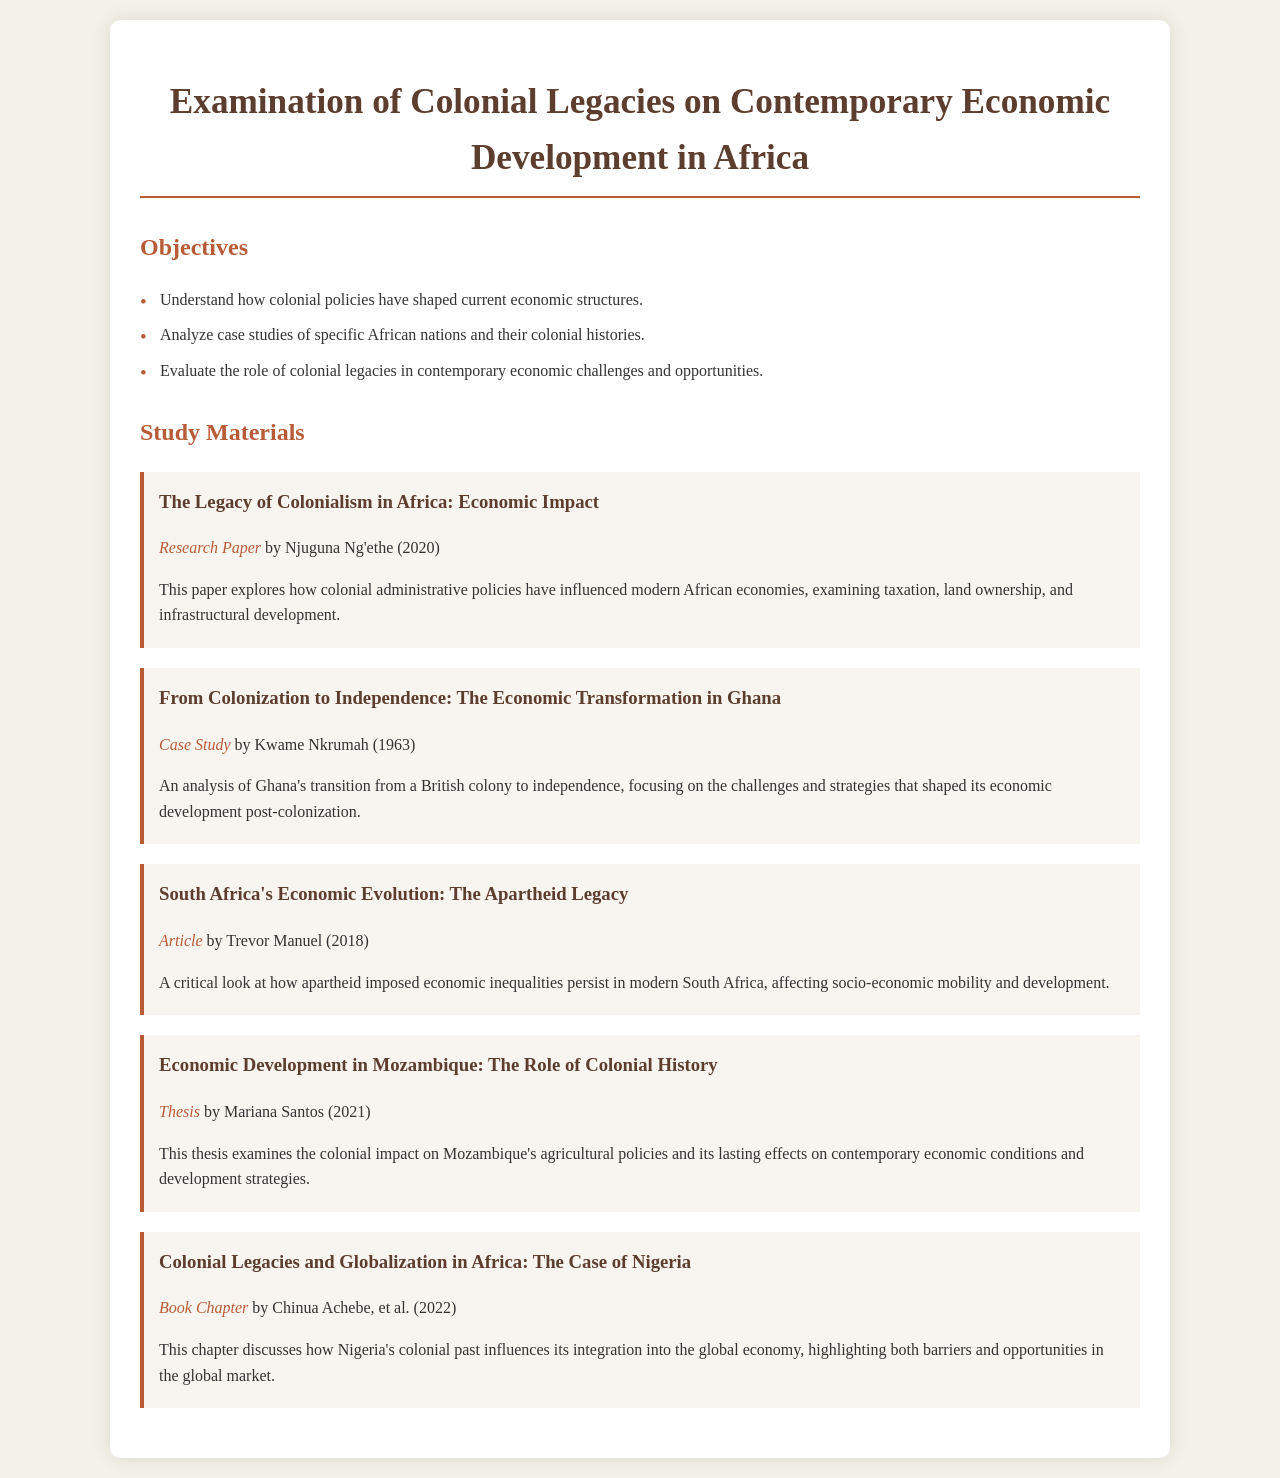What is the title of the document? The title of the document is presented at the very top of the rendered HTML, clearly indicated as the main heading.
Answer: Examination of Colonial Legacies on Contemporary Economic Development in Africa What is the first objective listed? The first objective is outlined in the list format under the "Objectives" section of the document.
Answer: Understand how colonial policies have shaped current economic structures Who authored the research paper on economic impact? The author's name can be found in the details of the study materials section related to the research paper.
Answer: Njuguna Ng'ethe What year was the case study on Ghana published? The publication year is found in parentheses next to the title of the case study in the study materials section.
Answer: 1963 Which country is analyzed in the case study by Mariana Santos? The specific country studied is mentioned directly in the title of Santos' thesis under the study materials section.
Answer: Mozambique What type of document is "South Africa's Economic Evolution: The Apartheid Legacy"? This information is derived from the description provided below the title in the study materials section.
Answer: Article What is the main focus of the book chapter by Chinua Achebe? The main focus is summarized in the description provided under the title in the study materials section.
Answer: Nigeria's colonial past influences its integration into the global economy How many study materials are listed in total? By counting the number of different material sections in the document, the total can be derived from the structure.
Answer: Five 